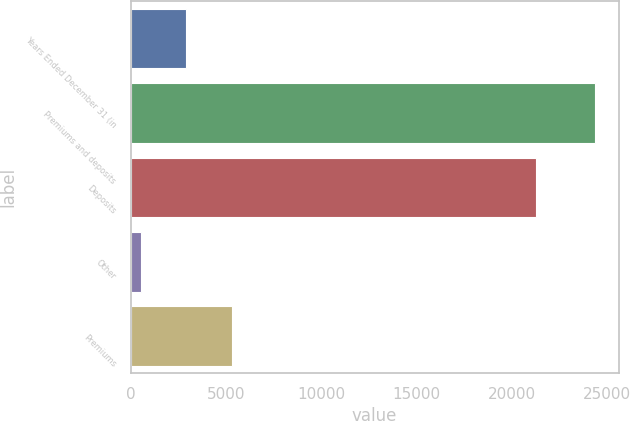Convert chart to OTSL. <chart><loc_0><loc_0><loc_500><loc_500><bar_chart><fcel>Years Ended December 31 (in<fcel>Premiums and deposits<fcel>Deposits<fcel>Other<fcel>Premiums<nl><fcel>2926.1<fcel>24392<fcel>21302<fcel>541<fcel>5311.2<nl></chart> 